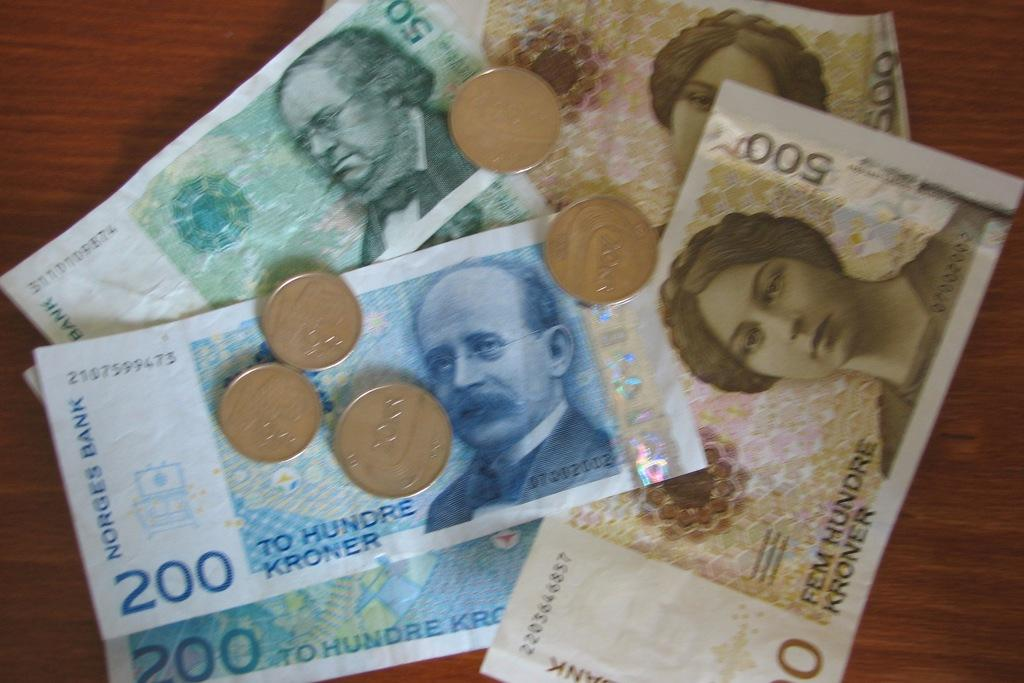What objects are on the table in the image? There are coins and currency notes on a table. Can you describe the objects on the table in more detail? The objects on the table are coins and currency notes. How does the wind affect the movement of the orange and soda in the image? There is no wind, orange, or soda present in the image. 